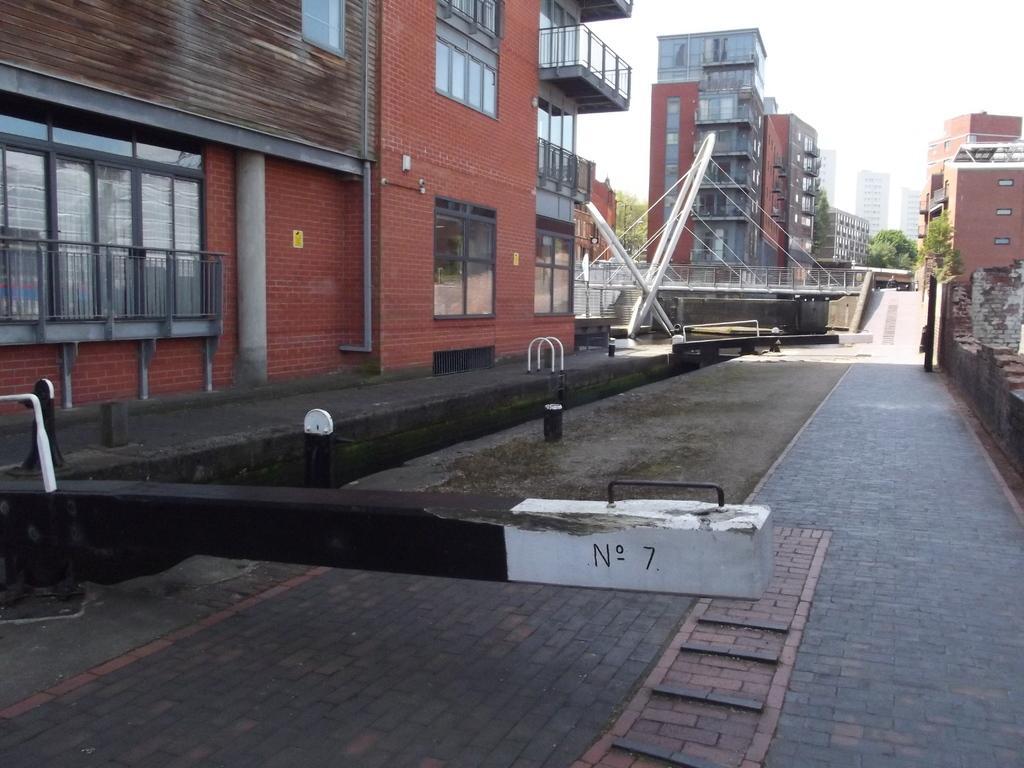Please provide a concise description of this image. In this picture I can see buildings, trees and a cloudy sky. 